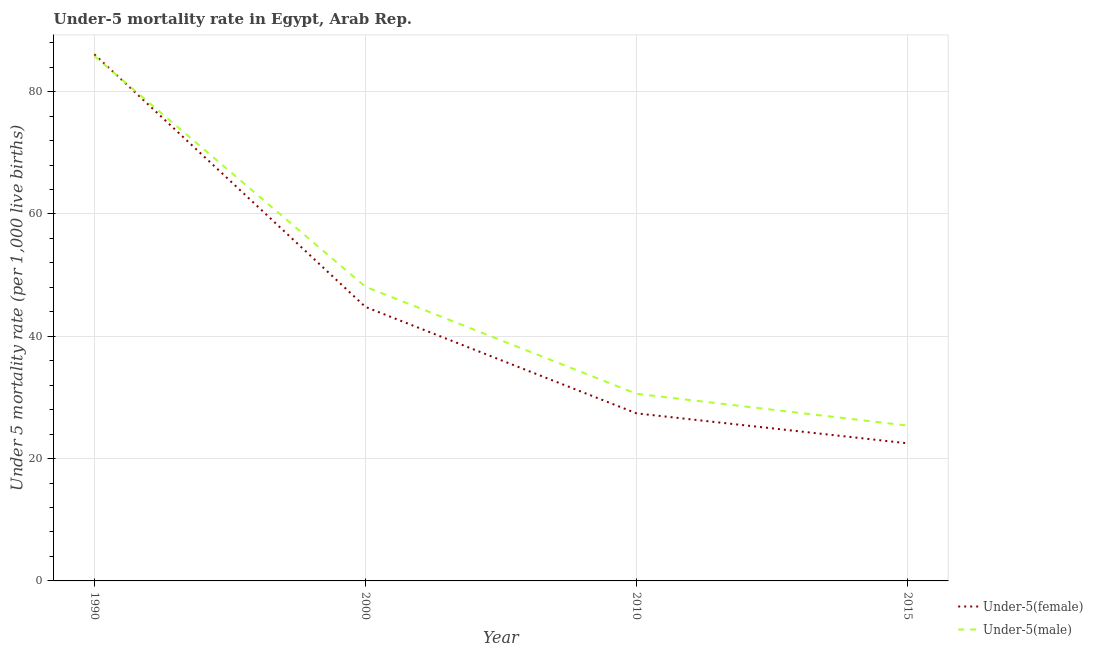How many different coloured lines are there?
Your response must be concise. 2. Does the line corresponding to under-5 female mortality rate intersect with the line corresponding to under-5 male mortality rate?
Offer a very short reply. Yes. What is the under-5 female mortality rate in 2000?
Your answer should be compact. 44.8. Across all years, what is the maximum under-5 male mortality rate?
Your answer should be very brief. 85.8. Across all years, what is the minimum under-5 male mortality rate?
Your answer should be very brief. 25.4. In which year was the under-5 male mortality rate maximum?
Make the answer very short. 1990. In which year was the under-5 female mortality rate minimum?
Offer a terse response. 2015. What is the total under-5 male mortality rate in the graph?
Your answer should be compact. 189.9. What is the difference between the under-5 female mortality rate in 2015 and the under-5 male mortality rate in 1990?
Your answer should be very brief. -63.3. What is the average under-5 female mortality rate per year?
Provide a succinct answer. 45.2. In the year 2015, what is the difference between the under-5 male mortality rate and under-5 female mortality rate?
Provide a succinct answer. 2.9. What is the ratio of the under-5 male mortality rate in 1990 to that in 2015?
Your response must be concise. 3.38. What is the difference between the highest and the second highest under-5 male mortality rate?
Offer a terse response. 37.7. What is the difference between the highest and the lowest under-5 female mortality rate?
Give a very brief answer. 63.6. Does the under-5 male mortality rate monotonically increase over the years?
Provide a succinct answer. No. Is the under-5 female mortality rate strictly greater than the under-5 male mortality rate over the years?
Your answer should be very brief. No. Is the under-5 female mortality rate strictly less than the under-5 male mortality rate over the years?
Make the answer very short. No. How many years are there in the graph?
Provide a short and direct response. 4. Does the graph contain any zero values?
Your response must be concise. No. What is the title of the graph?
Your response must be concise. Under-5 mortality rate in Egypt, Arab Rep. What is the label or title of the Y-axis?
Make the answer very short. Under 5 mortality rate (per 1,0 live births). What is the Under 5 mortality rate (per 1,000 live births) of Under-5(female) in 1990?
Make the answer very short. 86.1. What is the Under 5 mortality rate (per 1,000 live births) in Under-5(male) in 1990?
Ensure brevity in your answer.  85.8. What is the Under 5 mortality rate (per 1,000 live births) in Under-5(female) in 2000?
Your answer should be compact. 44.8. What is the Under 5 mortality rate (per 1,000 live births) of Under-5(male) in 2000?
Keep it short and to the point. 48.1. What is the Under 5 mortality rate (per 1,000 live births) of Under-5(female) in 2010?
Provide a succinct answer. 27.4. What is the Under 5 mortality rate (per 1,000 live births) in Under-5(male) in 2010?
Make the answer very short. 30.6. What is the Under 5 mortality rate (per 1,000 live births) of Under-5(male) in 2015?
Make the answer very short. 25.4. Across all years, what is the maximum Under 5 mortality rate (per 1,000 live births) in Under-5(female)?
Offer a very short reply. 86.1. Across all years, what is the maximum Under 5 mortality rate (per 1,000 live births) in Under-5(male)?
Ensure brevity in your answer.  85.8. Across all years, what is the minimum Under 5 mortality rate (per 1,000 live births) in Under-5(male)?
Your answer should be very brief. 25.4. What is the total Under 5 mortality rate (per 1,000 live births) of Under-5(female) in the graph?
Your answer should be very brief. 180.8. What is the total Under 5 mortality rate (per 1,000 live births) of Under-5(male) in the graph?
Offer a terse response. 189.9. What is the difference between the Under 5 mortality rate (per 1,000 live births) in Under-5(female) in 1990 and that in 2000?
Your response must be concise. 41.3. What is the difference between the Under 5 mortality rate (per 1,000 live births) in Under-5(male) in 1990 and that in 2000?
Ensure brevity in your answer.  37.7. What is the difference between the Under 5 mortality rate (per 1,000 live births) in Under-5(female) in 1990 and that in 2010?
Provide a succinct answer. 58.7. What is the difference between the Under 5 mortality rate (per 1,000 live births) of Under-5(male) in 1990 and that in 2010?
Provide a succinct answer. 55.2. What is the difference between the Under 5 mortality rate (per 1,000 live births) of Under-5(female) in 1990 and that in 2015?
Make the answer very short. 63.6. What is the difference between the Under 5 mortality rate (per 1,000 live births) of Under-5(male) in 1990 and that in 2015?
Your response must be concise. 60.4. What is the difference between the Under 5 mortality rate (per 1,000 live births) of Under-5(female) in 2000 and that in 2010?
Offer a very short reply. 17.4. What is the difference between the Under 5 mortality rate (per 1,000 live births) in Under-5(female) in 2000 and that in 2015?
Make the answer very short. 22.3. What is the difference between the Under 5 mortality rate (per 1,000 live births) in Under-5(male) in 2000 and that in 2015?
Ensure brevity in your answer.  22.7. What is the difference between the Under 5 mortality rate (per 1,000 live births) of Under-5(male) in 2010 and that in 2015?
Your answer should be very brief. 5.2. What is the difference between the Under 5 mortality rate (per 1,000 live births) of Under-5(female) in 1990 and the Under 5 mortality rate (per 1,000 live births) of Under-5(male) in 2010?
Offer a very short reply. 55.5. What is the difference between the Under 5 mortality rate (per 1,000 live births) in Under-5(female) in 1990 and the Under 5 mortality rate (per 1,000 live births) in Under-5(male) in 2015?
Your response must be concise. 60.7. What is the difference between the Under 5 mortality rate (per 1,000 live births) in Under-5(female) in 2000 and the Under 5 mortality rate (per 1,000 live births) in Under-5(male) in 2010?
Your answer should be very brief. 14.2. What is the difference between the Under 5 mortality rate (per 1,000 live births) of Under-5(female) in 2000 and the Under 5 mortality rate (per 1,000 live births) of Under-5(male) in 2015?
Ensure brevity in your answer.  19.4. What is the average Under 5 mortality rate (per 1,000 live births) in Under-5(female) per year?
Offer a very short reply. 45.2. What is the average Under 5 mortality rate (per 1,000 live births) of Under-5(male) per year?
Offer a terse response. 47.48. In the year 1990, what is the difference between the Under 5 mortality rate (per 1,000 live births) in Under-5(female) and Under 5 mortality rate (per 1,000 live births) in Under-5(male)?
Your answer should be compact. 0.3. In the year 2000, what is the difference between the Under 5 mortality rate (per 1,000 live births) of Under-5(female) and Under 5 mortality rate (per 1,000 live births) of Under-5(male)?
Your response must be concise. -3.3. In the year 2015, what is the difference between the Under 5 mortality rate (per 1,000 live births) in Under-5(female) and Under 5 mortality rate (per 1,000 live births) in Under-5(male)?
Offer a very short reply. -2.9. What is the ratio of the Under 5 mortality rate (per 1,000 live births) in Under-5(female) in 1990 to that in 2000?
Ensure brevity in your answer.  1.92. What is the ratio of the Under 5 mortality rate (per 1,000 live births) in Under-5(male) in 1990 to that in 2000?
Your response must be concise. 1.78. What is the ratio of the Under 5 mortality rate (per 1,000 live births) in Under-5(female) in 1990 to that in 2010?
Offer a terse response. 3.14. What is the ratio of the Under 5 mortality rate (per 1,000 live births) of Under-5(male) in 1990 to that in 2010?
Offer a very short reply. 2.8. What is the ratio of the Under 5 mortality rate (per 1,000 live births) of Under-5(female) in 1990 to that in 2015?
Provide a succinct answer. 3.83. What is the ratio of the Under 5 mortality rate (per 1,000 live births) of Under-5(male) in 1990 to that in 2015?
Give a very brief answer. 3.38. What is the ratio of the Under 5 mortality rate (per 1,000 live births) in Under-5(female) in 2000 to that in 2010?
Make the answer very short. 1.64. What is the ratio of the Under 5 mortality rate (per 1,000 live births) of Under-5(male) in 2000 to that in 2010?
Offer a terse response. 1.57. What is the ratio of the Under 5 mortality rate (per 1,000 live births) in Under-5(female) in 2000 to that in 2015?
Offer a very short reply. 1.99. What is the ratio of the Under 5 mortality rate (per 1,000 live births) in Under-5(male) in 2000 to that in 2015?
Give a very brief answer. 1.89. What is the ratio of the Under 5 mortality rate (per 1,000 live births) of Under-5(female) in 2010 to that in 2015?
Make the answer very short. 1.22. What is the ratio of the Under 5 mortality rate (per 1,000 live births) of Under-5(male) in 2010 to that in 2015?
Make the answer very short. 1.2. What is the difference between the highest and the second highest Under 5 mortality rate (per 1,000 live births) in Under-5(female)?
Your answer should be very brief. 41.3. What is the difference between the highest and the second highest Under 5 mortality rate (per 1,000 live births) of Under-5(male)?
Provide a succinct answer. 37.7. What is the difference between the highest and the lowest Under 5 mortality rate (per 1,000 live births) of Under-5(female)?
Give a very brief answer. 63.6. What is the difference between the highest and the lowest Under 5 mortality rate (per 1,000 live births) of Under-5(male)?
Your answer should be compact. 60.4. 